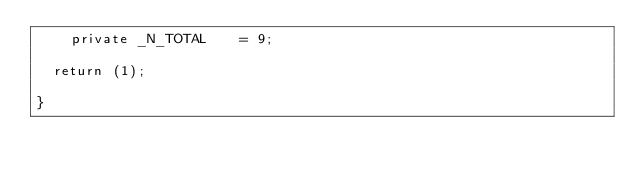Convert code to text. <code><loc_0><loc_0><loc_500><loc_500><_SML_>    private _N_TOTAL		= 9;

	return (1);

}















</code> 